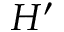<formula> <loc_0><loc_0><loc_500><loc_500>H ^ { \prime }</formula> 